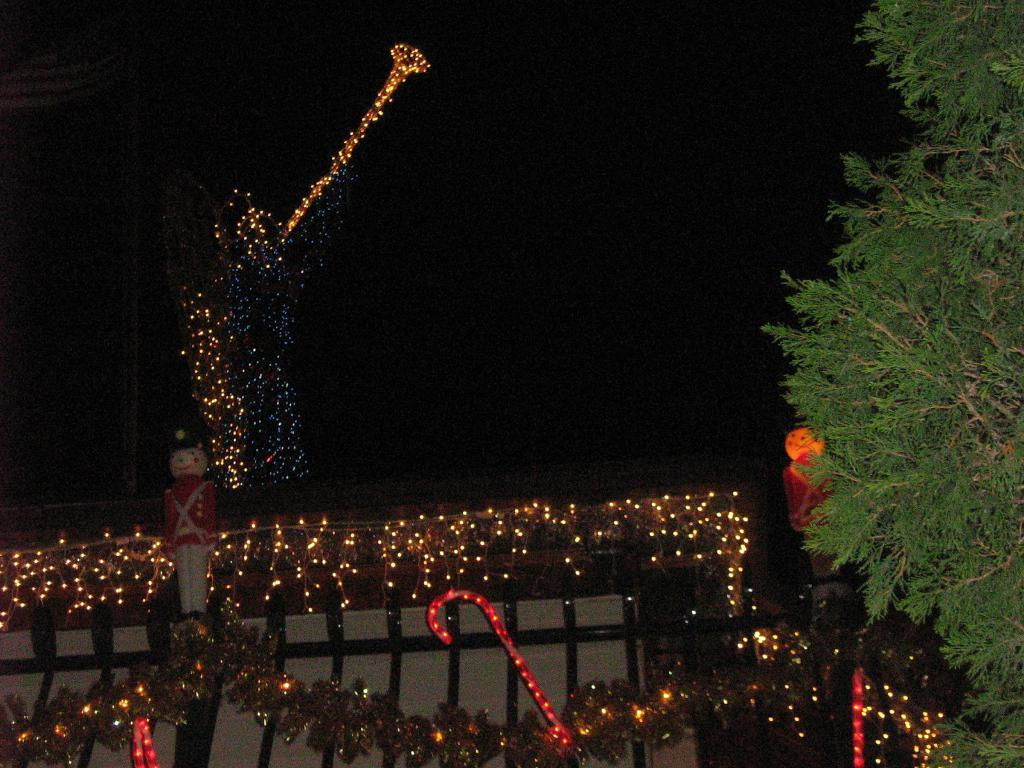What is located in the middle of the image? There are lightings, a tree, a house, toys, and the sky visible in the middle of the image. Can you describe the tree in the image? The tree in the image is in the middle of the image. What is the condition of the sky in the image? The sky is visible in the middle of the image. How many pails of water are being drained in the image? There are no pails or draining of water present in the image. Is anyone shown sleeping in the image? There is no indication of anyone sleeping in the image. 